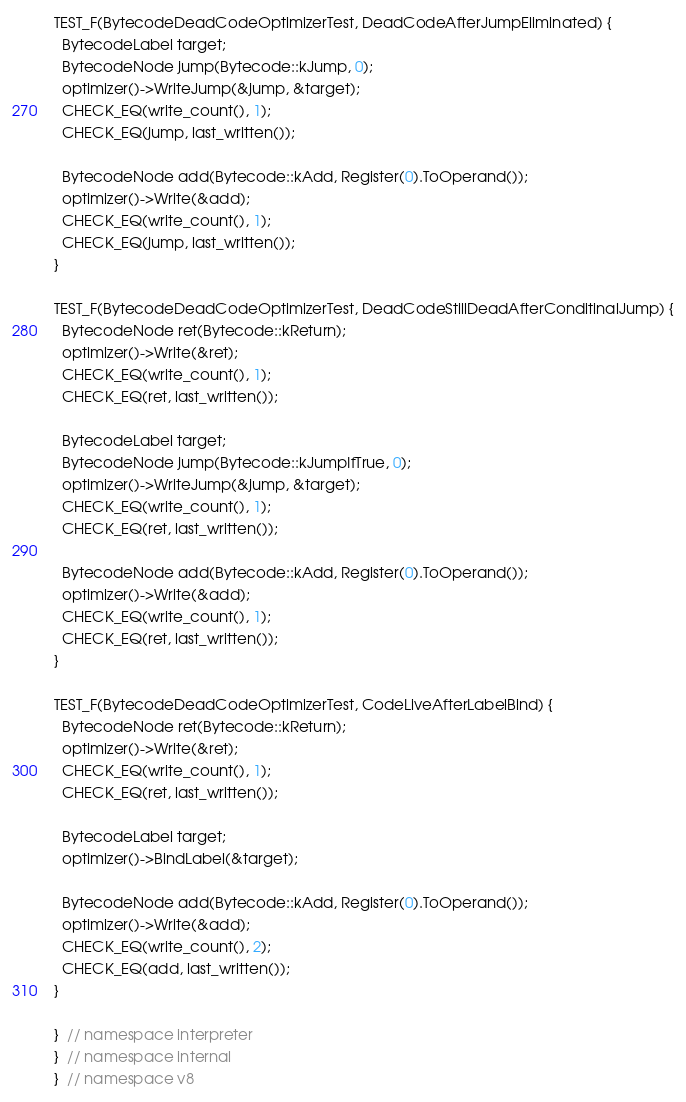Convert code to text. <code><loc_0><loc_0><loc_500><loc_500><_C++_>
TEST_F(BytecodeDeadCodeOptimizerTest, DeadCodeAfterJumpEliminated) {
  BytecodeLabel target;
  BytecodeNode jump(Bytecode::kJump, 0);
  optimizer()->WriteJump(&jump, &target);
  CHECK_EQ(write_count(), 1);
  CHECK_EQ(jump, last_written());

  BytecodeNode add(Bytecode::kAdd, Register(0).ToOperand());
  optimizer()->Write(&add);
  CHECK_EQ(write_count(), 1);
  CHECK_EQ(jump, last_written());
}

TEST_F(BytecodeDeadCodeOptimizerTest, DeadCodeStillDeadAfterConditinalJump) {
  BytecodeNode ret(Bytecode::kReturn);
  optimizer()->Write(&ret);
  CHECK_EQ(write_count(), 1);
  CHECK_EQ(ret, last_written());

  BytecodeLabel target;
  BytecodeNode jump(Bytecode::kJumpIfTrue, 0);
  optimizer()->WriteJump(&jump, &target);
  CHECK_EQ(write_count(), 1);
  CHECK_EQ(ret, last_written());

  BytecodeNode add(Bytecode::kAdd, Register(0).ToOperand());
  optimizer()->Write(&add);
  CHECK_EQ(write_count(), 1);
  CHECK_EQ(ret, last_written());
}

TEST_F(BytecodeDeadCodeOptimizerTest, CodeLiveAfterLabelBind) {
  BytecodeNode ret(Bytecode::kReturn);
  optimizer()->Write(&ret);
  CHECK_EQ(write_count(), 1);
  CHECK_EQ(ret, last_written());

  BytecodeLabel target;
  optimizer()->BindLabel(&target);

  BytecodeNode add(Bytecode::kAdd, Register(0).ToOperand());
  optimizer()->Write(&add);
  CHECK_EQ(write_count(), 2);
  CHECK_EQ(add, last_written());
}

}  // namespace interpreter
}  // namespace internal
}  // namespace v8
</code> 